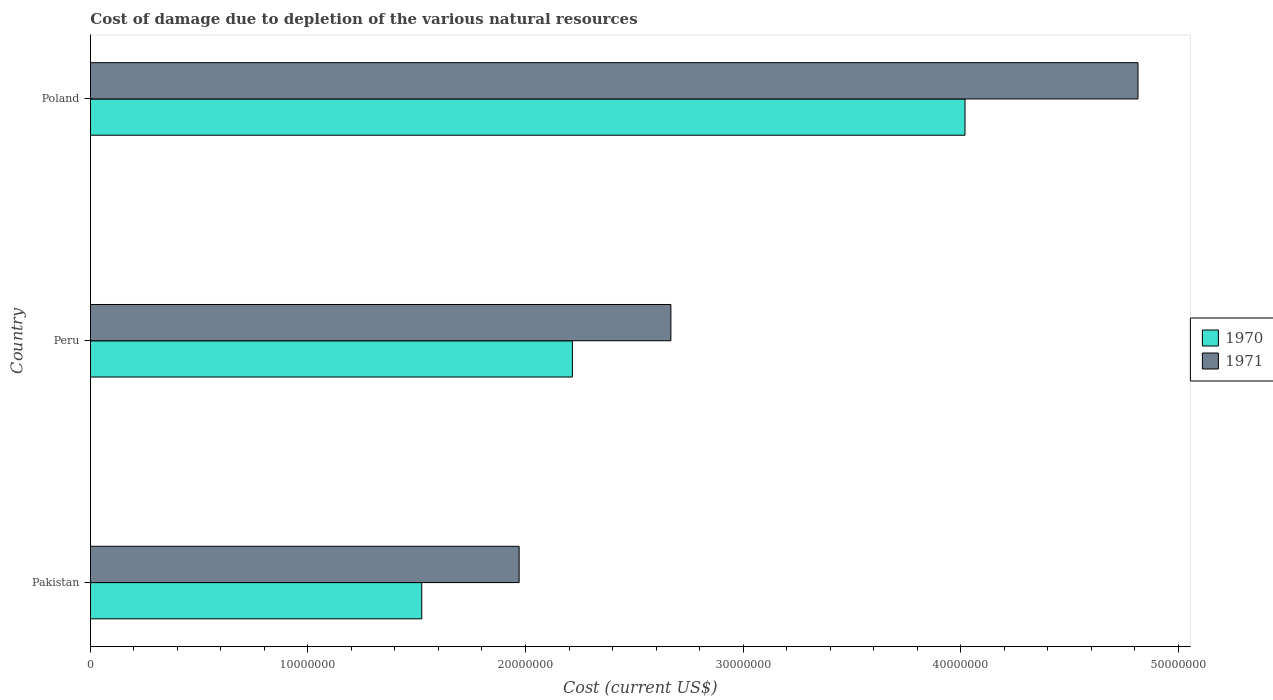Are the number of bars per tick equal to the number of legend labels?
Your answer should be very brief. Yes. What is the label of the 3rd group of bars from the top?
Provide a succinct answer. Pakistan. In how many cases, is the number of bars for a given country not equal to the number of legend labels?
Provide a succinct answer. 0. What is the cost of damage caused due to the depletion of various natural resources in 1970 in Pakistan?
Ensure brevity in your answer.  1.52e+07. Across all countries, what is the maximum cost of damage caused due to the depletion of various natural resources in 1970?
Make the answer very short. 4.02e+07. Across all countries, what is the minimum cost of damage caused due to the depletion of various natural resources in 1970?
Offer a terse response. 1.52e+07. In which country was the cost of damage caused due to the depletion of various natural resources in 1971 minimum?
Make the answer very short. Pakistan. What is the total cost of damage caused due to the depletion of various natural resources in 1970 in the graph?
Offer a terse response. 7.76e+07. What is the difference between the cost of damage caused due to the depletion of various natural resources in 1971 in Pakistan and that in Poland?
Provide a succinct answer. -2.84e+07. What is the difference between the cost of damage caused due to the depletion of various natural resources in 1971 in Poland and the cost of damage caused due to the depletion of various natural resources in 1970 in Peru?
Offer a terse response. 2.60e+07. What is the average cost of damage caused due to the depletion of various natural resources in 1970 per country?
Give a very brief answer. 2.59e+07. What is the difference between the cost of damage caused due to the depletion of various natural resources in 1970 and cost of damage caused due to the depletion of various natural resources in 1971 in Poland?
Keep it short and to the point. -7.95e+06. In how many countries, is the cost of damage caused due to the depletion of various natural resources in 1970 greater than 48000000 US$?
Offer a very short reply. 0. What is the ratio of the cost of damage caused due to the depletion of various natural resources in 1971 in Pakistan to that in Poland?
Your answer should be very brief. 0.41. Is the difference between the cost of damage caused due to the depletion of various natural resources in 1970 in Peru and Poland greater than the difference between the cost of damage caused due to the depletion of various natural resources in 1971 in Peru and Poland?
Offer a very short reply. Yes. What is the difference between the highest and the second highest cost of damage caused due to the depletion of various natural resources in 1971?
Offer a very short reply. 2.15e+07. What is the difference between the highest and the lowest cost of damage caused due to the depletion of various natural resources in 1971?
Make the answer very short. 2.84e+07. In how many countries, is the cost of damage caused due to the depletion of various natural resources in 1970 greater than the average cost of damage caused due to the depletion of various natural resources in 1970 taken over all countries?
Provide a short and direct response. 1. What does the 2nd bar from the bottom in Peru represents?
Your answer should be compact. 1971. How many legend labels are there?
Your answer should be very brief. 2. How are the legend labels stacked?
Your response must be concise. Vertical. What is the title of the graph?
Provide a succinct answer. Cost of damage due to depletion of the various natural resources. What is the label or title of the X-axis?
Provide a short and direct response. Cost (current US$). What is the Cost (current US$) of 1970 in Pakistan?
Make the answer very short. 1.52e+07. What is the Cost (current US$) of 1971 in Pakistan?
Your answer should be very brief. 1.97e+07. What is the Cost (current US$) of 1970 in Peru?
Your answer should be compact. 2.22e+07. What is the Cost (current US$) of 1971 in Peru?
Offer a terse response. 2.67e+07. What is the Cost (current US$) of 1970 in Poland?
Ensure brevity in your answer.  4.02e+07. What is the Cost (current US$) of 1971 in Poland?
Offer a very short reply. 4.82e+07. Across all countries, what is the maximum Cost (current US$) in 1970?
Your response must be concise. 4.02e+07. Across all countries, what is the maximum Cost (current US$) of 1971?
Provide a succinct answer. 4.82e+07. Across all countries, what is the minimum Cost (current US$) of 1970?
Make the answer very short. 1.52e+07. Across all countries, what is the minimum Cost (current US$) of 1971?
Offer a terse response. 1.97e+07. What is the total Cost (current US$) in 1970 in the graph?
Offer a terse response. 7.76e+07. What is the total Cost (current US$) of 1971 in the graph?
Offer a very short reply. 9.45e+07. What is the difference between the Cost (current US$) of 1970 in Pakistan and that in Peru?
Provide a succinct answer. -6.92e+06. What is the difference between the Cost (current US$) of 1971 in Pakistan and that in Peru?
Give a very brief answer. -6.98e+06. What is the difference between the Cost (current US$) in 1970 in Pakistan and that in Poland?
Give a very brief answer. -2.50e+07. What is the difference between the Cost (current US$) of 1971 in Pakistan and that in Poland?
Your answer should be very brief. -2.84e+07. What is the difference between the Cost (current US$) in 1970 in Peru and that in Poland?
Your answer should be very brief. -1.80e+07. What is the difference between the Cost (current US$) of 1971 in Peru and that in Poland?
Provide a short and direct response. -2.15e+07. What is the difference between the Cost (current US$) in 1970 in Pakistan and the Cost (current US$) in 1971 in Peru?
Give a very brief answer. -1.15e+07. What is the difference between the Cost (current US$) in 1970 in Pakistan and the Cost (current US$) in 1971 in Poland?
Provide a short and direct response. -3.29e+07. What is the difference between the Cost (current US$) in 1970 in Peru and the Cost (current US$) in 1971 in Poland?
Provide a short and direct response. -2.60e+07. What is the average Cost (current US$) of 1970 per country?
Provide a succinct answer. 2.59e+07. What is the average Cost (current US$) in 1971 per country?
Give a very brief answer. 3.15e+07. What is the difference between the Cost (current US$) of 1970 and Cost (current US$) of 1971 in Pakistan?
Provide a succinct answer. -4.48e+06. What is the difference between the Cost (current US$) in 1970 and Cost (current US$) in 1971 in Peru?
Ensure brevity in your answer.  -4.53e+06. What is the difference between the Cost (current US$) of 1970 and Cost (current US$) of 1971 in Poland?
Your answer should be very brief. -7.95e+06. What is the ratio of the Cost (current US$) in 1970 in Pakistan to that in Peru?
Provide a short and direct response. 0.69. What is the ratio of the Cost (current US$) of 1971 in Pakistan to that in Peru?
Your answer should be compact. 0.74. What is the ratio of the Cost (current US$) in 1970 in Pakistan to that in Poland?
Provide a short and direct response. 0.38. What is the ratio of the Cost (current US$) of 1971 in Pakistan to that in Poland?
Offer a very short reply. 0.41. What is the ratio of the Cost (current US$) in 1970 in Peru to that in Poland?
Keep it short and to the point. 0.55. What is the ratio of the Cost (current US$) in 1971 in Peru to that in Poland?
Offer a terse response. 0.55. What is the difference between the highest and the second highest Cost (current US$) of 1970?
Your answer should be compact. 1.80e+07. What is the difference between the highest and the second highest Cost (current US$) of 1971?
Provide a succinct answer. 2.15e+07. What is the difference between the highest and the lowest Cost (current US$) of 1970?
Keep it short and to the point. 2.50e+07. What is the difference between the highest and the lowest Cost (current US$) of 1971?
Give a very brief answer. 2.84e+07. 